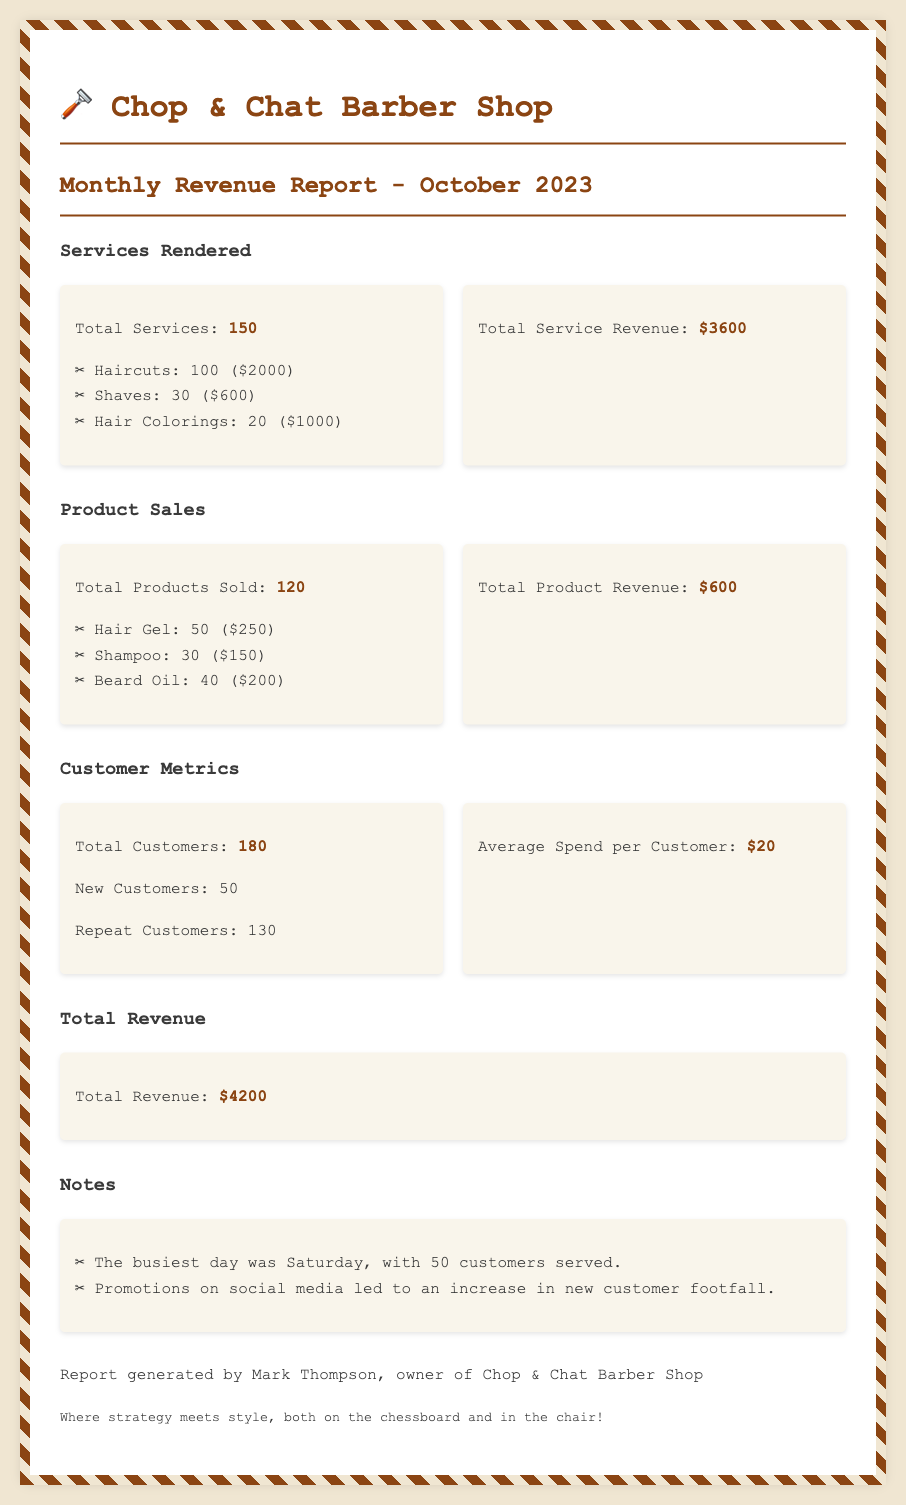What is the total revenue? The total revenue is mentioned in the document as the final figure, which is $4200.
Answer: $4200 How many haircuts were performed? The document lists the number of haircuts performed as part of the services rendered, totaling 100.
Answer: 100 What was the revenue from hair colorings? The revenue from hair colorings is detailed in the services section, which amounts to $1000.
Answer: $1000 How many new customers visited? The number of new customers is specified under customer metrics, totaling 50.
Answer: 50 What was the average spend per customer? The average spend per customer is provided as a key metric in the document, which is $20.
Answer: $20 What is the total number of products sold? The document states the total products sold under the product sales section, which is 120.
Answer: 120 Which day was the busiest? The document notes that Saturday was the busiest day, serving 50 customers.
Answer: Saturday How many repeat customers were there? The count of repeat customers is specified in the customer metrics as 130.
Answer: 130 What was the total revenue from product sales? Total product revenue is given as part of the product sales section, totaling $600.
Answer: $600 